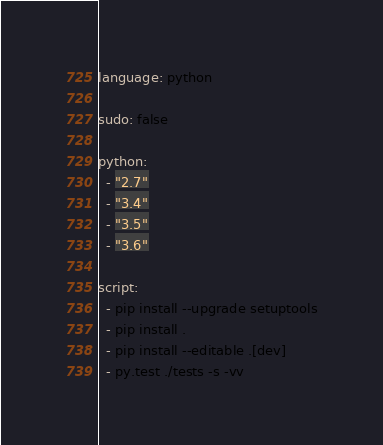<code> <loc_0><loc_0><loc_500><loc_500><_YAML_>language: python

sudo: false

python:
  - "2.7"
  - "3.4"
  - "3.5"
  - "3.6"

script:
  - pip install --upgrade setuptools
  - pip install .
  - pip install --editable .[dev]
  - py.test ./tests -s -vv
</code> 